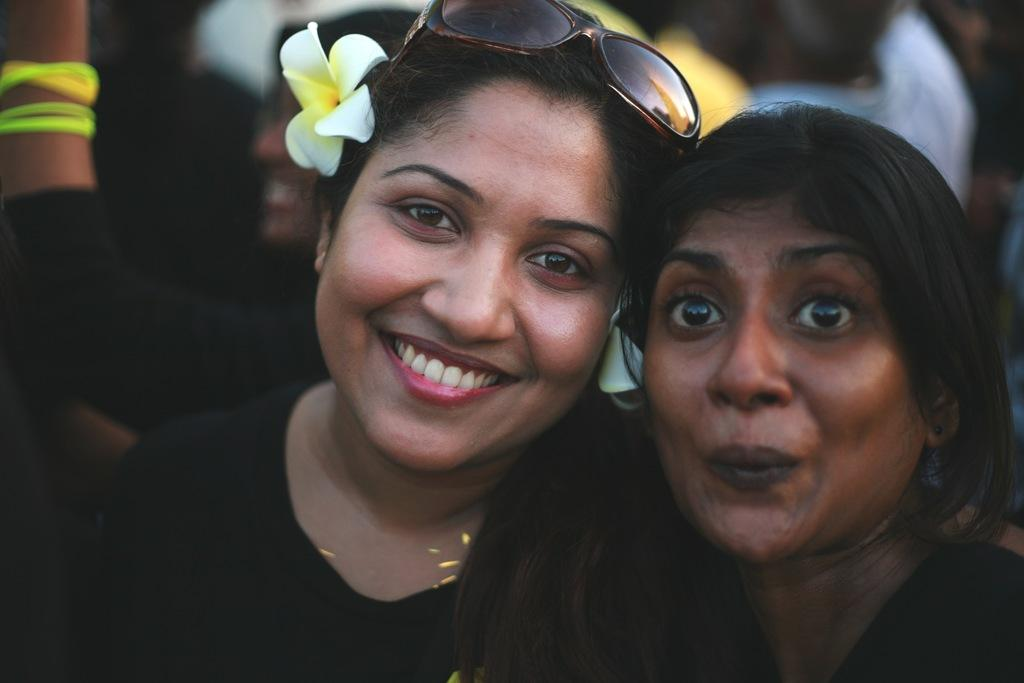How many people are in the image? There are two women in the image. What is the facial expression of the women? Both women are smiling. Can you describe any accessories worn by the women? One of the women has a flower in her ear. How would you describe the background of the image? The background of the image is blurred. What type of cap is the woman wearing in the image? There is no cap visible on either woman in the image. Can you tell me what type of bed is in the background of the image? There is no bed present in the image; the background is blurred. 